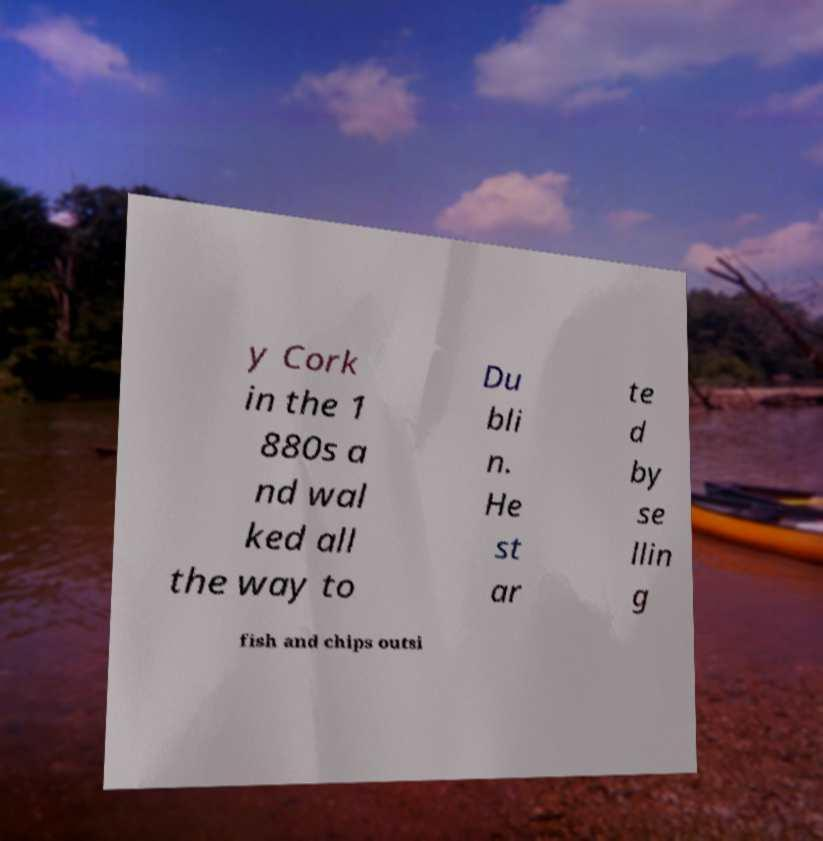There's text embedded in this image that I need extracted. Can you transcribe it verbatim? y Cork in the 1 880s a nd wal ked all the way to Du bli n. He st ar te d by se llin g fish and chips outsi 